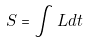Convert formula to latex. <formula><loc_0><loc_0><loc_500><loc_500>S = \int L d t</formula> 